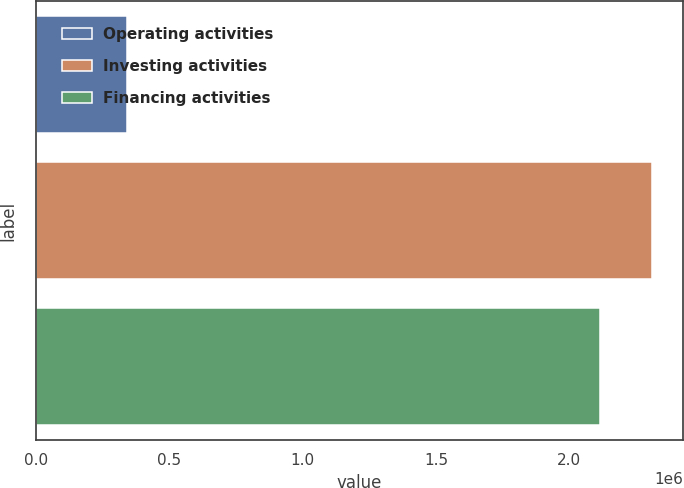<chart> <loc_0><loc_0><loc_500><loc_500><bar_chart><fcel>Operating activities<fcel>Investing activities<fcel>Financing activities<nl><fcel>340914<fcel>2.30983e+06<fcel>2.11641e+06<nl></chart> 